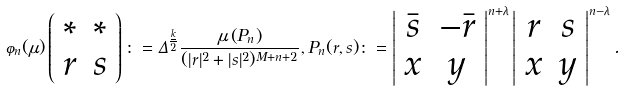<formula> <loc_0><loc_0><loc_500><loc_500>\varphi _ { n } ( \mu ) \left ( \begin{array} { c c } \ast & \ast \\ r & s \end{array} \right ) \colon = \Delta ^ { \frac { \underline { k } } { 2 } } \frac { \mu \left ( P _ { n } \right ) } { ( | r | ^ { 2 } + | s | ^ { 2 } ) ^ { M + n + 2 } } , P _ { n } ( r , s ) \colon = \left | \begin{array} { c c } \bar { s } & - \bar { r } \\ x & y \end{array} \right | ^ { n + \lambda } \left | \begin{array} { c c } r & s \\ x & y \end{array} \right | ^ { n - \lambda } .</formula> 